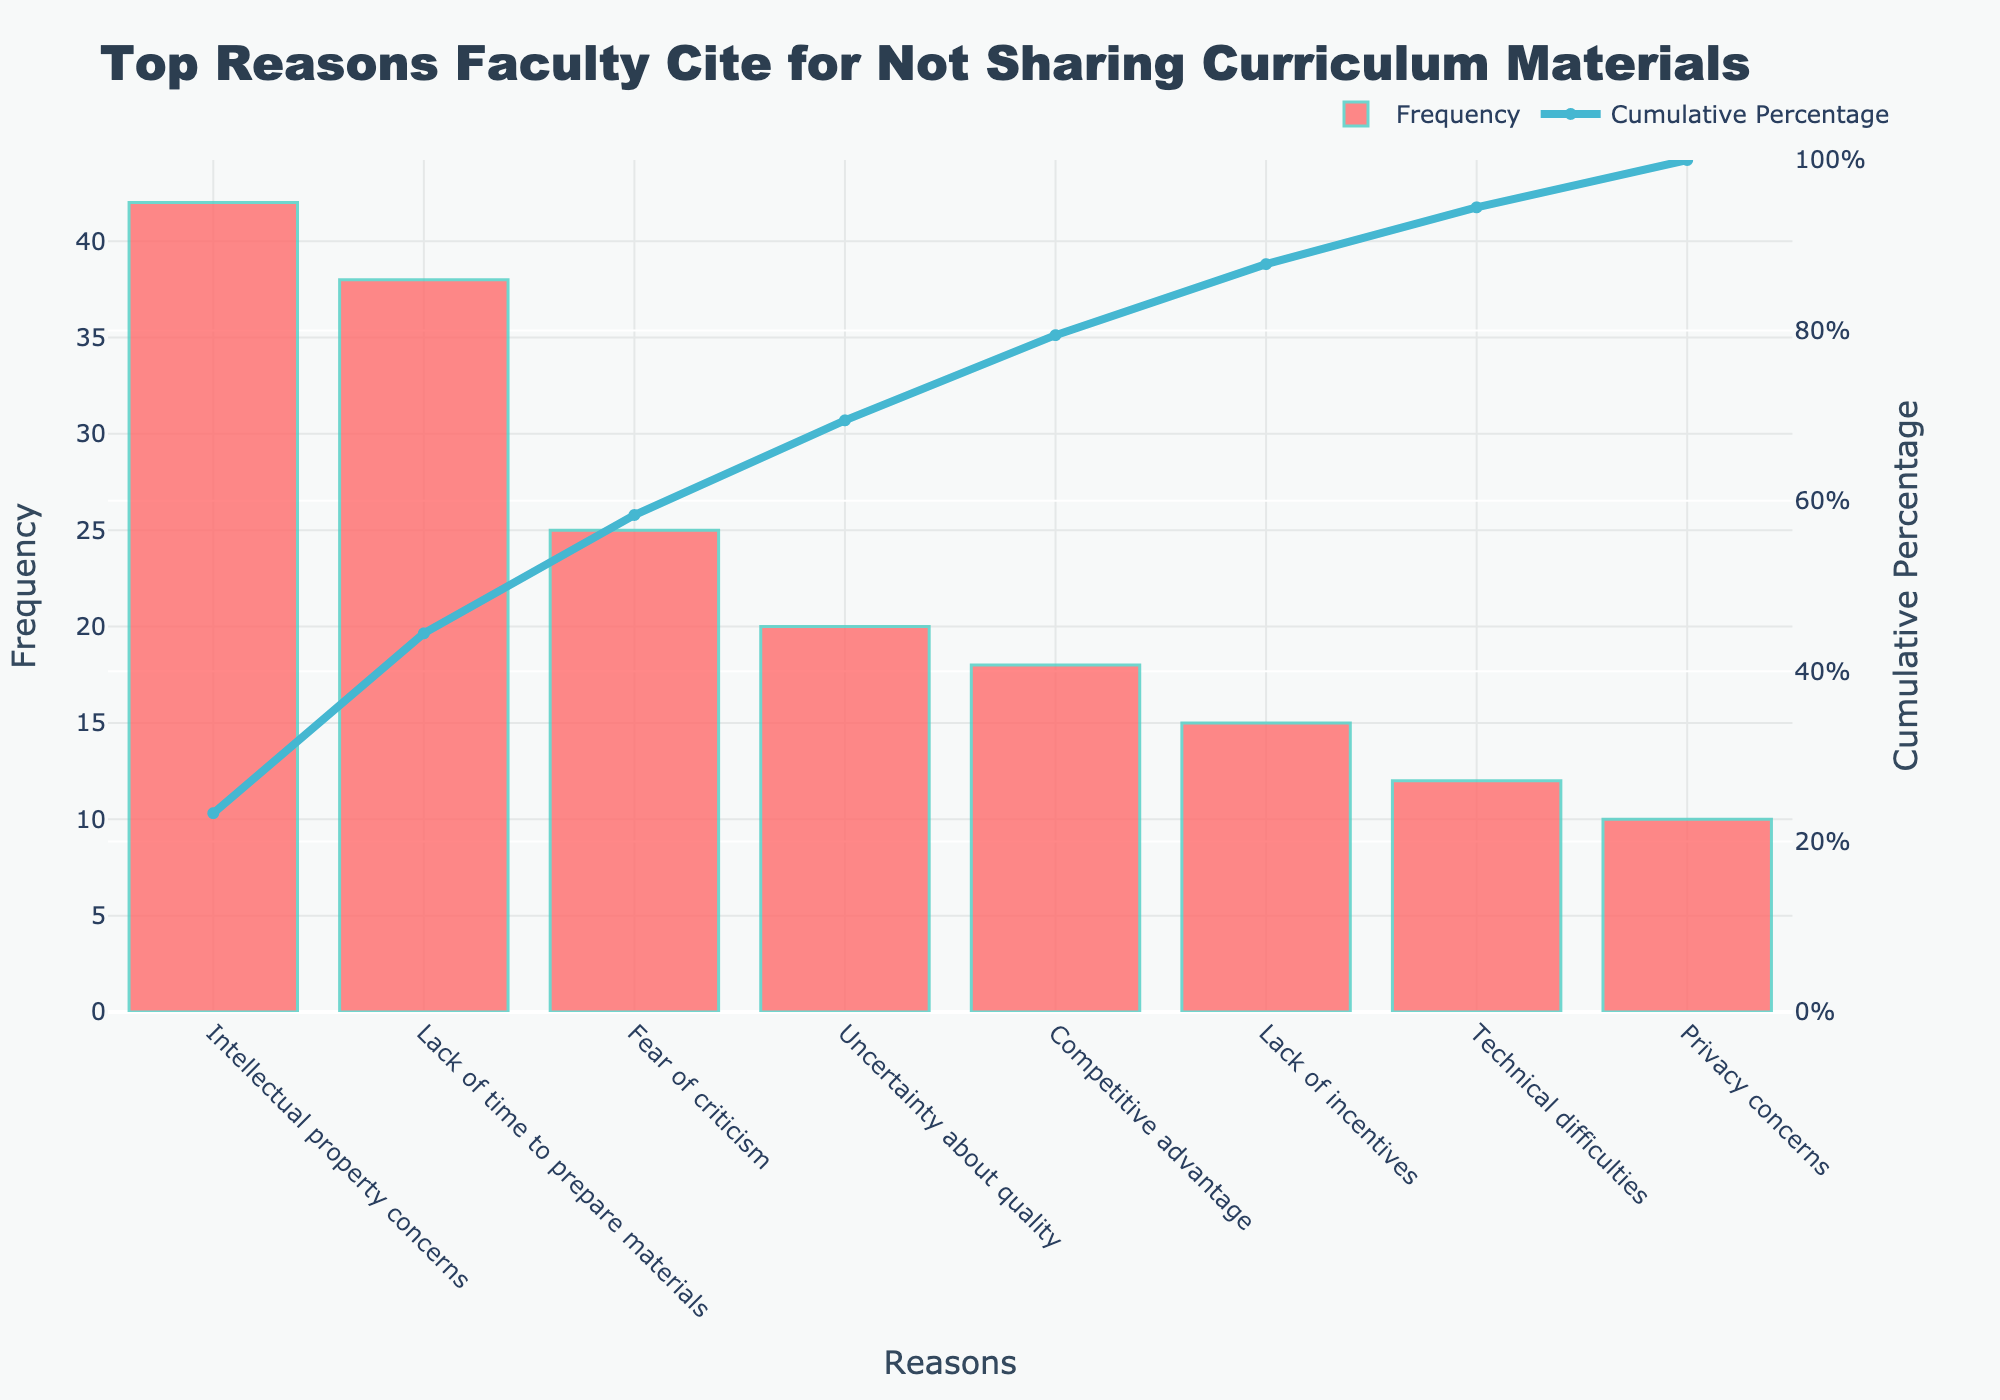What's the highest frequency reason for not sharing curriculum materials? The highest bar in the chart represents the most frequent reason. This corresponds to "Intellectual property concerns," with a frequency of 42.
Answer: Intellectual property concerns Which reason has the lowest frequency? The shortest bar in the chart represents the least frequent reason. This corresponds to "Privacy concerns," with a frequency of 10.
Answer: Privacy concerns What is the cumulative percentage at "Fear of criticism"? To find the cumulative percentage at "Fear of criticism," check the line graph's value at that point. The line graph shows approximately 73.0%.
Answer: Approximately 73.0% How many reasons have frequencies higher than 20? Identify the bars higher than the frequency value of 20. These reasons are "Intellectual property concerns" and "Lack of time to prepare materials." Thus, there are 3 reasons.
Answer: 3 What is the difference in frequency between "Lack of incentives" and "Competitive advantage"? Find the frequency values for both reasons: "Competitive advantage" is 18, and "Lack of incentives" is 15. Subtract the latter from the former: 18 - 15 = 3.
Answer: 3 Do "Intellectual property concerns" and "Lack of time to prepare materials" constitute more than half of the cumulative percentage? Sum their frequencies: 42 + 38 = 80. Calculate the percentage of this sum out of the total frequency, which is 180. (80 / 180) * 100 = 44.44%. Therefore, they do not constitute more than half.
Answer: No Which reason has the second-highest cumulative percentage? Refer to the line graph's endpoint right before the highest cumulative percentage. The second-highest cumulative percentage is at "Lack of time to prepare materials."
Answer: Lack of time to prepare materials How does "Technical difficulties" compare to "Privacy concerns" in terms of frequency? Compare their respective bar heights. "Technical difficulties" has a frequency of 12, which is higher than "Privacy concerns" at 10.
Answer: Higher What percentage of the reasons form approximately the top 80% of the cumulative percentage? Check the line graph to see where it intersects with the 80% mark. The reasons up to "Uncertainty about quality" roughly account for 80%. This includes 4 reasons.
Answer: 4 What is the combined frequency of reasons with cumulative percentages less than 50%? The cumulative percentages less than 50% include "Intellectual property concerns," "Lack of time to prepare materials," and part of "Fear of criticism." Sum these up: 42 + 38 + 25 = 105. Until Fear of criticism is included, the total is 105.
Answer: 105 